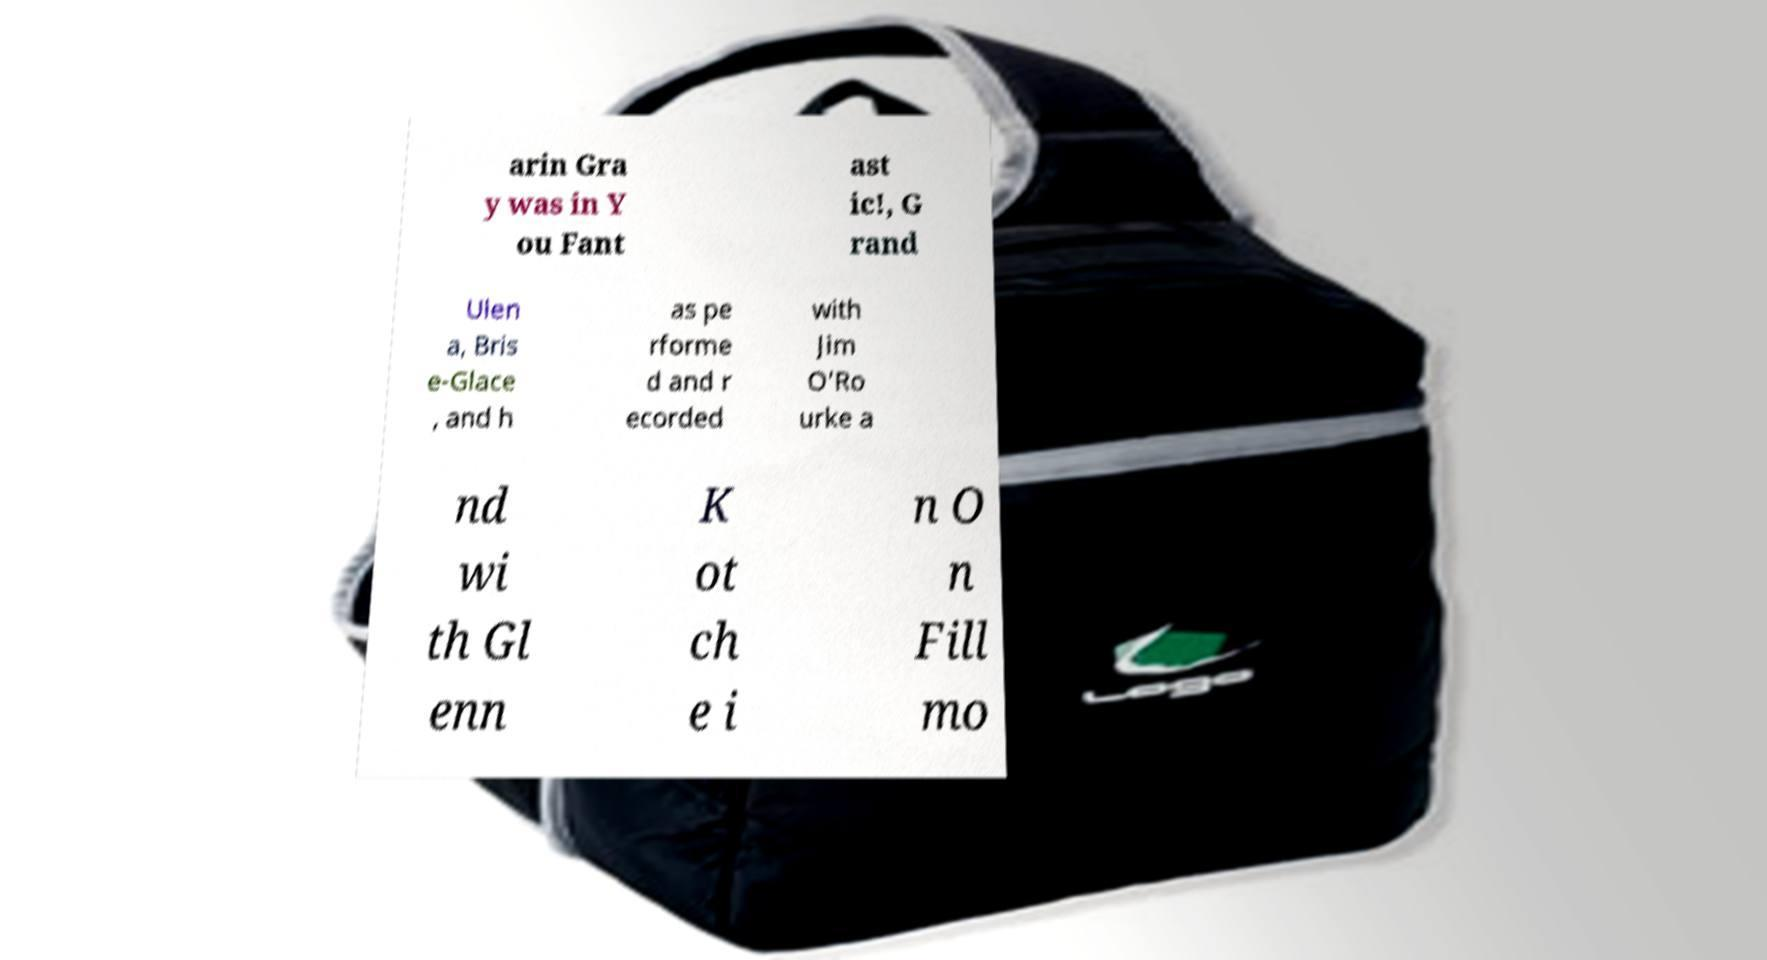Please identify and transcribe the text found in this image. arin Gra y was in Y ou Fant ast ic!, G rand Ulen a, Bris e-Glace , and h as pe rforme d and r ecorded with Jim O'Ro urke a nd wi th Gl enn K ot ch e i n O n Fill mo 